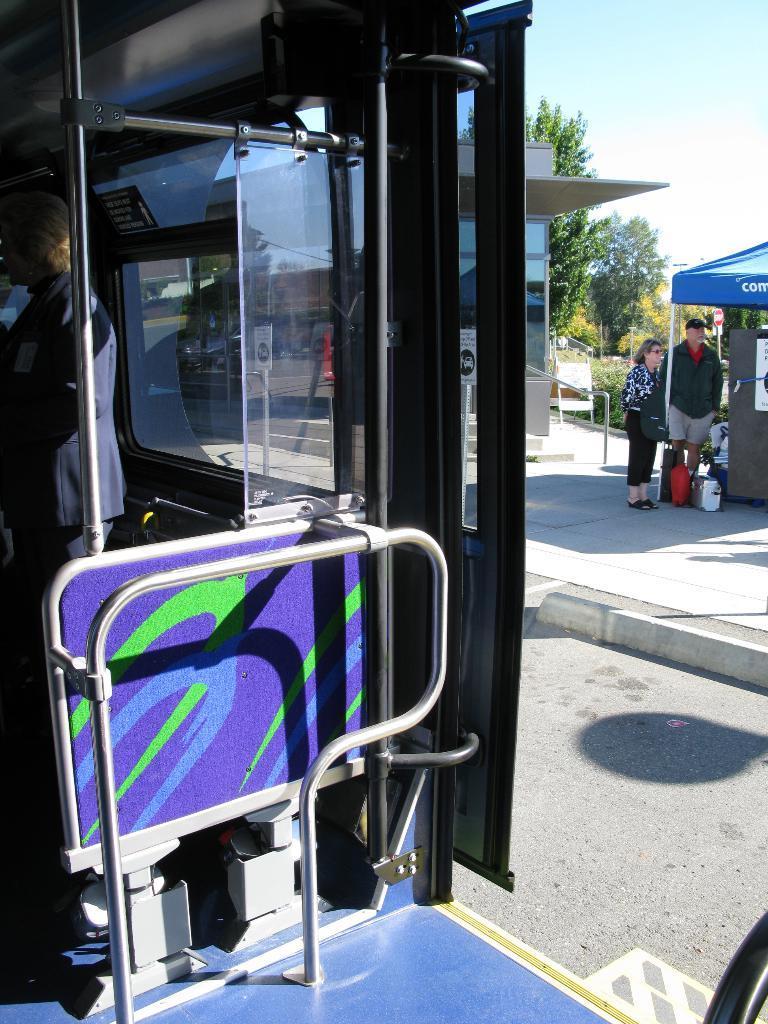Please provide a concise description of this image. On the left side, there is a person in a suit, standing in a vehicle which is having glass windows, poles and a door. In the background, there is a woman and a man standing near a blue color tent, there are trees, plants, there are clouds in the blue sky and there are other objects. 